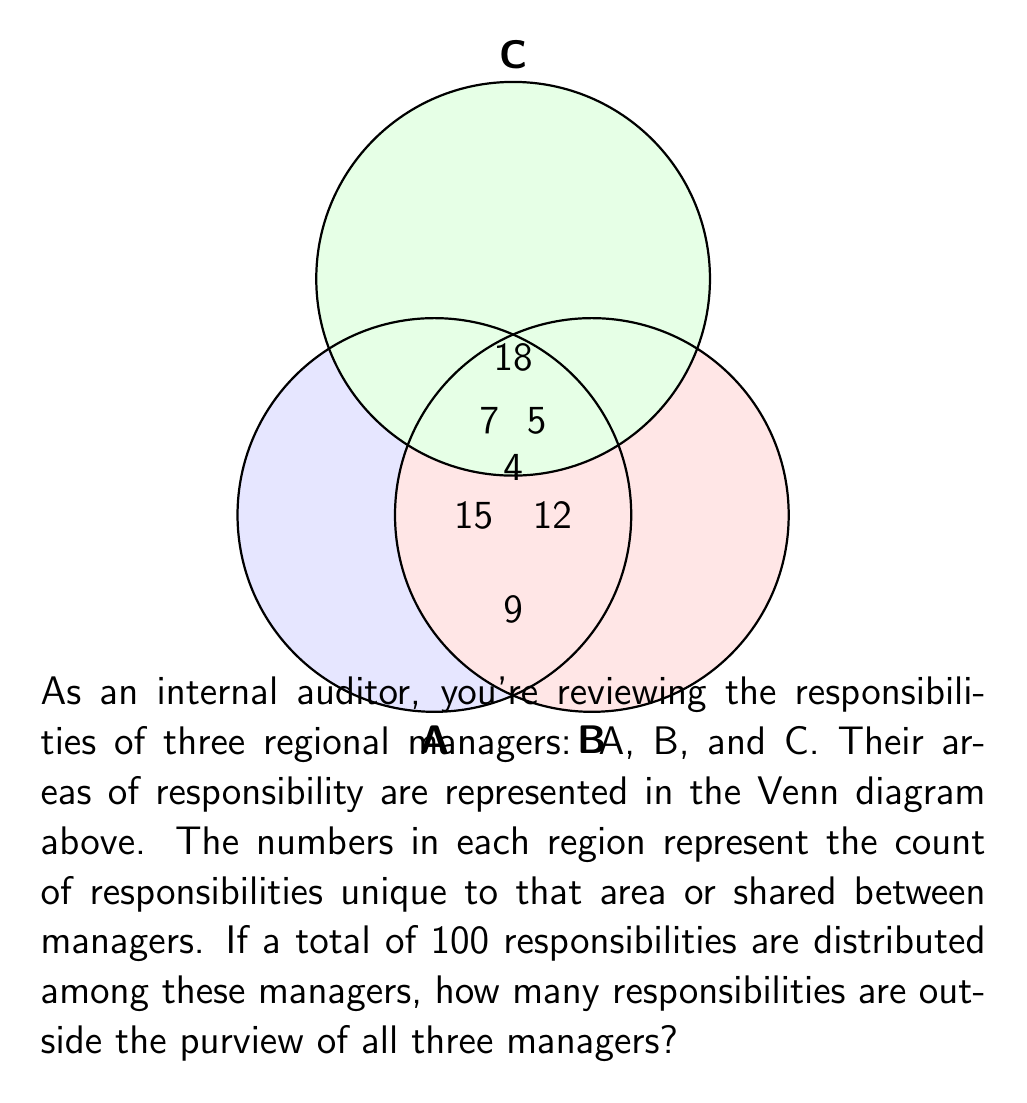Can you answer this question? Let's approach this step-by-step:

1) First, let's calculate the total number of responsibilities covered by the managers:

   $15 + 12 + 18 + 7 + 5 + 9 + 4 = 70$

2) We know that there are 100 total responsibilities. To find the number of responsibilities outside all three managers' purview, we need to subtract the responsibilities covered by the managers from the total:

   $100 - 70 = 30$

3) We can verify this using set theory. If we define:
   $U$ = Universal set (all responsibilities)
   $A$ = Responsibilities of manager A
   $B$ = Responsibilities of manager B
   $C$ = Responsibilities of manager C

   Then we're looking for: $|U - (A \cup B \cup C)|$

4) This is equivalent to:
   $|U| - |A \cup B \cup C|$

5) We know $|U| = 100$ and $|A \cup B \cup C| = 70$

Therefore, $|U - (A \cup B \cup C)| = 100 - 70 = 30$

This confirms our initial calculation.
Answer: 30 responsibilities 